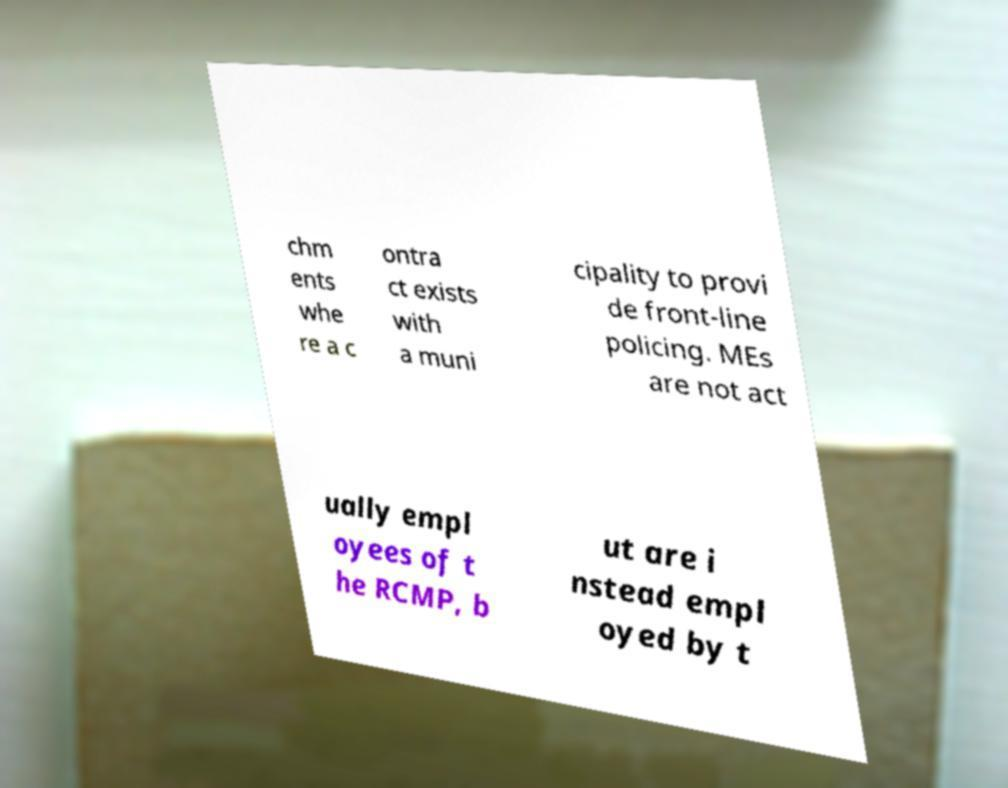Can you accurately transcribe the text from the provided image for me? chm ents whe re a c ontra ct exists with a muni cipality to provi de front-line policing. MEs are not act ually empl oyees of t he RCMP, b ut are i nstead empl oyed by t 